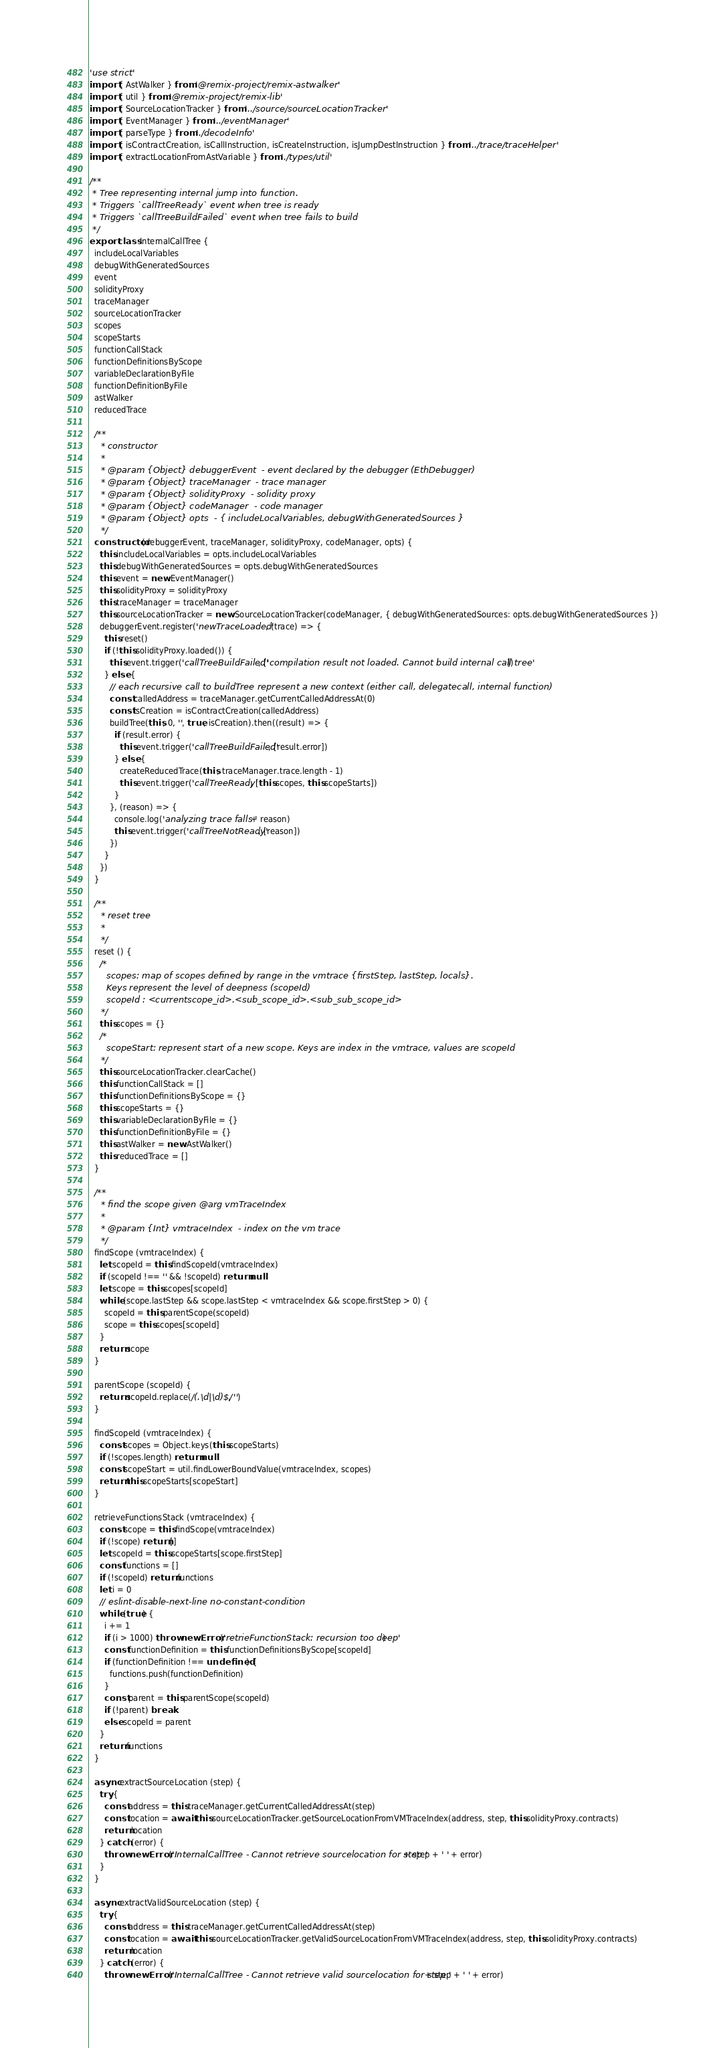Convert code to text. <code><loc_0><loc_0><loc_500><loc_500><_TypeScript_>'use strict'
import { AstWalker } from '@remix-project/remix-astwalker'
import { util } from '@remix-project/remix-lib'
import { SourceLocationTracker } from '../source/sourceLocationTracker'
import { EventManager } from '../eventManager'
import { parseType } from './decodeInfo'
import { isContractCreation, isCallInstruction, isCreateInstruction, isJumpDestInstruction } from '../trace/traceHelper'
import { extractLocationFromAstVariable } from './types/util'

/**
 * Tree representing internal jump into function.
 * Triggers `callTreeReady` event when tree is ready
 * Triggers `callTreeBuildFailed` event when tree fails to build
 */
export class InternalCallTree {
  includeLocalVariables
  debugWithGeneratedSources
  event
  solidityProxy
  traceManager
  sourceLocationTracker
  scopes
  scopeStarts
  functionCallStack
  functionDefinitionsByScope
  variableDeclarationByFile
  functionDefinitionByFile
  astWalker
  reducedTrace

  /**
    * constructor
    *
    * @param {Object} debuggerEvent  - event declared by the debugger (EthDebugger)
    * @param {Object} traceManager  - trace manager
    * @param {Object} solidityProxy  - solidity proxy
    * @param {Object} codeManager  - code manager
    * @param {Object} opts  - { includeLocalVariables, debugWithGeneratedSources }
    */
  constructor (debuggerEvent, traceManager, solidityProxy, codeManager, opts) {
    this.includeLocalVariables = opts.includeLocalVariables
    this.debugWithGeneratedSources = opts.debugWithGeneratedSources
    this.event = new EventManager()
    this.solidityProxy = solidityProxy
    this.traceManager = traceManager
    this.sourceLocationTracker = new SourceLocationTracker(codeManager, { debugWithGeneratedSources: opts.debugWithGeneratedSources })
    debuggerEvent.register('newTraceLoaded', (trace) => {
      this.reset()
      if (!this.solidityProxy.loaded()) {
        this.event.trigger('callTreeBuildFailed', ['compilation result not loaded. Cannot build internal call tree'])
      } else {
        // each recursive call to buildTree represent a new context (either call, delegatecall, internal function)
        const calledAddress = traceManager.getCurrentCalledAddressAt(0)
        const isCreation = isContractCreation(calledAddress)
        buildTree(this, 0, '', true, isCreation).then((result) => {
          if (result.error) {
            this.event.trigger('callTreeBuildFailed', [result.error])
          } else {
            createReducedTrace(this, traceManager.trace.length - 1)
            this.event.trigger('callTreeReady', [this.scopes, this.scopeStarts])
          }
        }, (reason) => {
          console.log('analyzing trace falls ' + reason)
          this.event.trigger('callTreeNotReady', [reason])
        })
      }
    })
  }

  /**
    * reset tree
    *
    */
  reset () {
    /*
      scopes: map of scopes defined by range in the vmtrace {firstStep, lastStep, locals}.
      Keys represent the level of deepness (scopeId)
      scopeId : <currentscope_id>.<sub_scope_id>.<sub_sub_scope_id>
    */
    this.scopes = {}
    /*
      scopeStart: represent start of a new scope. Keys are index in the vmtrace, values are scopeId
    */
    this.sourceLocationTracker.clearCache()
    this.functionCallStack = []
    this.functionDefinitionsByScope = {}
    this.scopeStarts = {}
    this.variableDeclarationByFile = {}
    this.functionDefinitionByFile = {}
    this.astWalker = new AstWalker()
    this.reducedTrace = []
  }

  /**
    * find the scope given @arg vmTraceIndex
    *
    * @param {Int} vmtraceIndex  - index on the vm trace
    */
  findScope (vmtraceIndex) {
    let scopeId = this.findScopeId(vmtraceIndex)
    if (scopeId !== '' && !scopeId) return null
    let scope = this.scopes[scopeId]
    while (scope.lastStep && scope.lastStep < vmtraceIndex && scope.firstStep > 0) {
      scopeId = this.parentScope(scopeId)
      scope = this.scopes[scopeId]
    }
    return scope
  }

  parentScope (scopeId) {
    return scopeId.replace(/(.\d|\d)$/, '')
  }

  findScopeId (vmtraceIndex) {
    const scopes = Object.keys(this.scopeStarts)
    if (!scopes.length) return null
    const scopeStart = util.findLowerBoundValue(vmtraceIndex, scopes)
    return this.scopeStarts[scopeStart]
  }

  retrieveFunctionsStack (vmtraceIndex) {
    const scope = this.findScope(vmtraceIndex)
    if (!scope) return []
    let scopeId = this.scopeStarts[scope.firstStep]
    const functions = []
    if (!scopeId) return functions
    let i = 0
    // eslint-disable-next-line no-constant-condition
    while (true) {
      i += 1
      if (i > 1000) throw new Error('retrieFunctionStack: recursion too deep')
      const functionDefinition = this.functionDefinitionsByScope[scopeId]
      if (functionDefinition !== undefined) {
        functions.push(functionDefinition)
      }
      const parent = this.parentScope(scopeId)
      if (!parent) break
      else scopeId = parent
    }
    return functions
  }

  async extractSourceLocation (step) {
    try {
      const address = this.traceManager.getCurrentCalledAddressAt(step)
      const location = await this.sourceLocationTracker.getSourceLocationFromVMTraceIndex(address, step, this.solidityProxy.contracts)
      return location
    } catch (error) {
      throw new Error('InternalCallTree - Cannot retrieve sourcelocation for step ' + step + ' ' + error)
    }
  }

  async extractValidSourceLocation (step) {
    try {
      const address = this.traceManager.getCurrentCalledAddressAt(step)
      const location = await this.sourceLocationTracker.getValidSourceLocationFromVMTraceIndex(address, step, this.solidityProxy.contracts)
      return location
    } catch (error) {
      throw new Error('InternalCallTree - Cannot retrieve valid sourcelocation for step ' + step + ' ' + error)</code> 